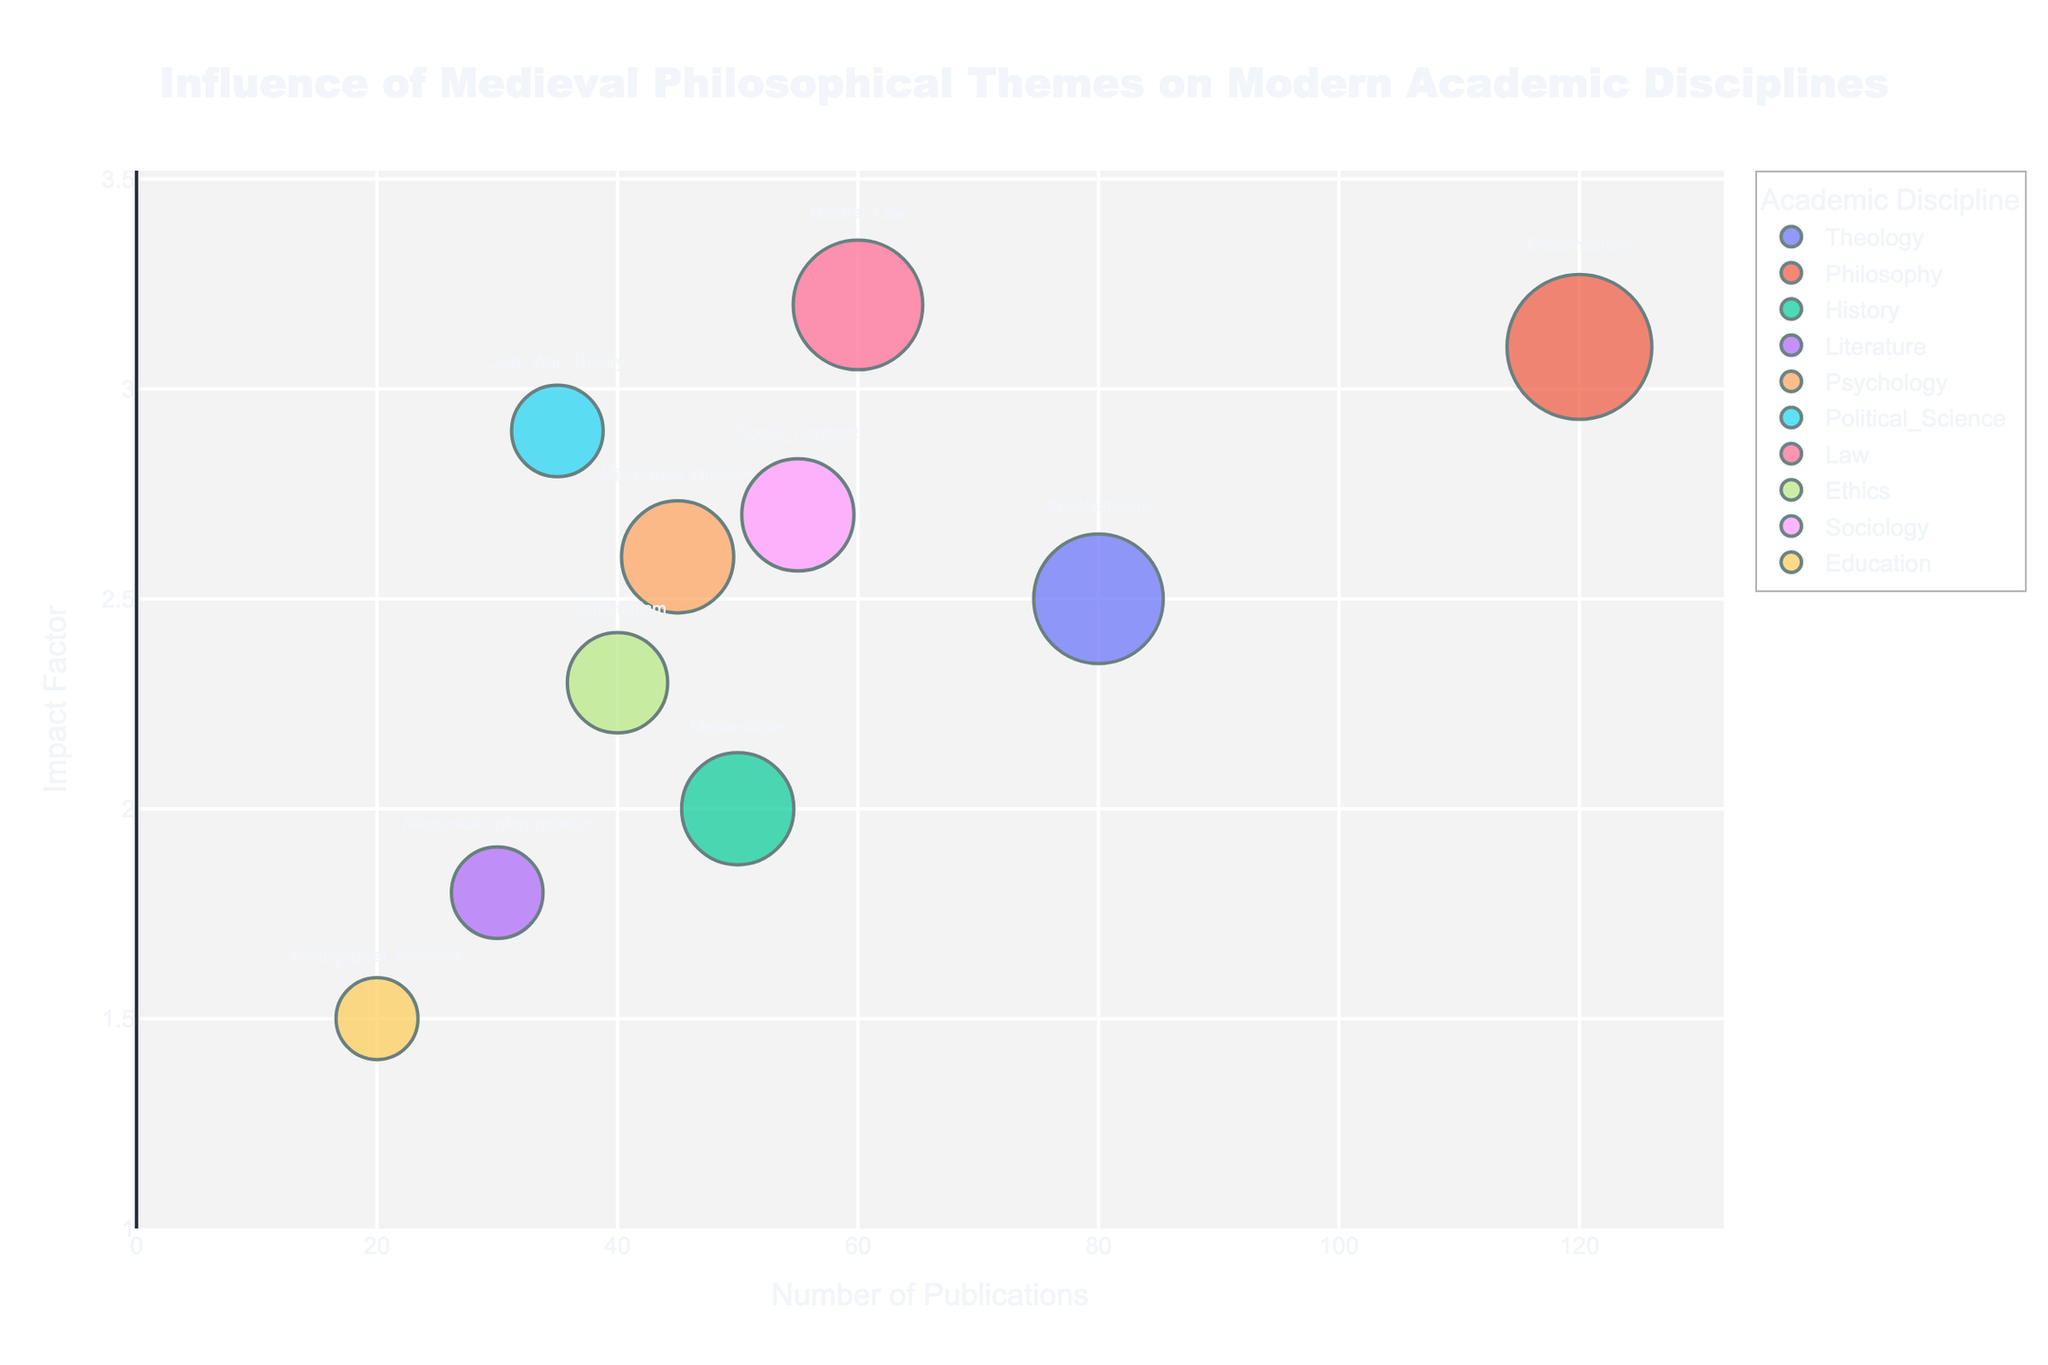what is the title of the bubble chart? The title of the bubble chart is displayed at the top of the figure. It reads 'Influence of Medieval Philosophical Themes on Modern Academic Disciplines'.
Answer: 'Influence of Medieval Philosophical Themes on Modern Academic Disciplines' how many publication categories are displayed in the chart? Each bubble represents a different category, and their color indicates different academic disciplines. By counting the unique colors and categories, we see there are 10 categories.
Answer: 10 which academic discipline has the highest number of publications? By looking at the x-axis, we find the bubble farthest to the right. This corresponds to 'Philosophy' with 120 publications.
Answer: Philosophy what theme is linked with the law discipline and what is its impact factor? The bubble representing the 'Law' discipline can be identified by its label. The theme is 'Natural Law' and its y-position indicates an impact factor of 3.2.
Answer: Natural Law, 3.2 which fields share the same field proportion of 0.15? By looking at the bubble sizes and checking the labels, we can identify that 'History', 'Psychology', and 'Sociology' all share a field proportion of 0.15.
Answer: History, Psychology, Sociology how does the impact factor of 'Just War Theory' compare to 'Mind-Body Dualism'? The y-axis indicates the impact factor: 'Just War Theory' in Political Science has 2.9, while 'Mind-Body Dualism' in Psychology has 2.6. 2.9 > 2.6.
Answer: Just War Theory > Mind-Body Dualism which theme has the smallest number of publications? By looking at the bubbles closest to the left on the x-axis, 'Pedagogical Methods' in Education has the smallest number of publications, which is 20.
Answer: Pedagogical Methods what is the average impact factor of all themes? Add all impact factors (2.5, 3.1, 2.0, 1.8, 2.6, 2.9, 3.2, 2.3, 2.7, 1.5) to get 24.6, then divide by the number of themes (10) to get the average: 24.6 / 10 = 2.46.
Answer: 2.46 rank the disciplines by their marker size in ascending order. The marker size is proportionate to the field proportion. The field proportions in ascending order: Education 0.08, Literature 0.1, Political Science 0.1, Ethics 0.12, History 0.15, Psychology 0.15, Sociology 0.15, Theology 0.2, Law 0.2, Philosophy 0.25. This gives the corresponding disciplines in order.
Answer: Education, Literature, Political Science, Ethics, History, Psychology, Sociology, Theology, Law, Philosophy which themes have an impact factor greater than 3.0? By looking at bubbles above the 3.0 mark on the y-axis, the themes are 'Existentialism' in Philosophy and 'Natural Law' in Law.
Answer: Existentialism, Natural Law 